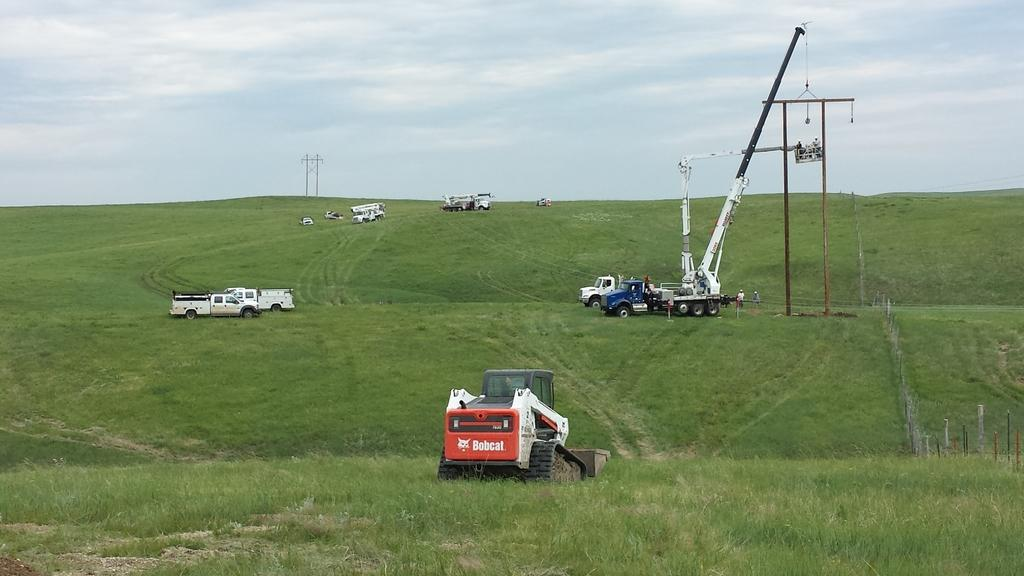What can be seen on the grassland in the foreground area of the image? There are vehicles and poles on the grassland in the foreground area of the image. Can you describe the poles in the foreground area of the image? Yes, there are poles on the grassland in the foreground area of the image. What is visible in the background area of the image? The sky is visible in the background area of the image. Are there any poles in the background area of the image? No, there are no poles mentioned in the background area of the image. What type of weather can be seen in the image? The provided facts do not mention any specific weather conditions in the image. How does the impulse affect the vehicles in the image? There is no mention of an impulse affecting the vehicles in the image. 